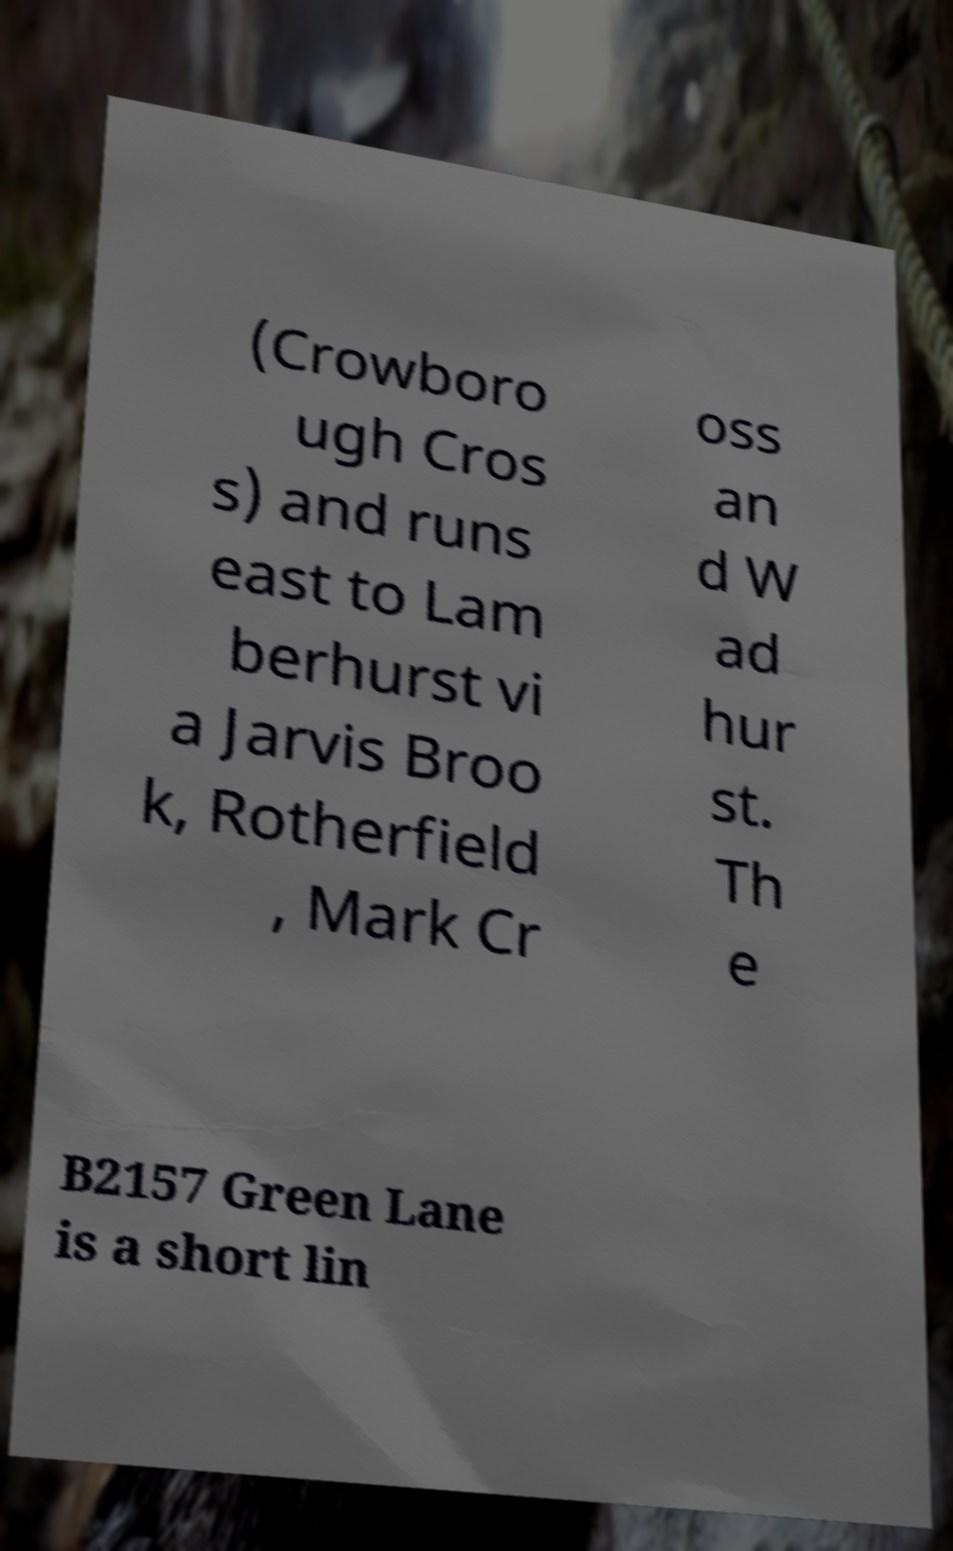Could you assist in decoding the text presented in this image and type it out clearly? (Crowboro ugh Cros s) and runs east to Lam berhurst vi a Jarvis Broo k, Rotherfield , Mark Cr oss an d W ad hur st. Th e B2157 Green Lane is a short lin 